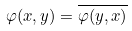Convert formula to latex. <formula><loc_0><loc_0><loc_500><loc_500>\varphi ( x , y ) = \overline { \varphi ( y , x ) }</formula> 